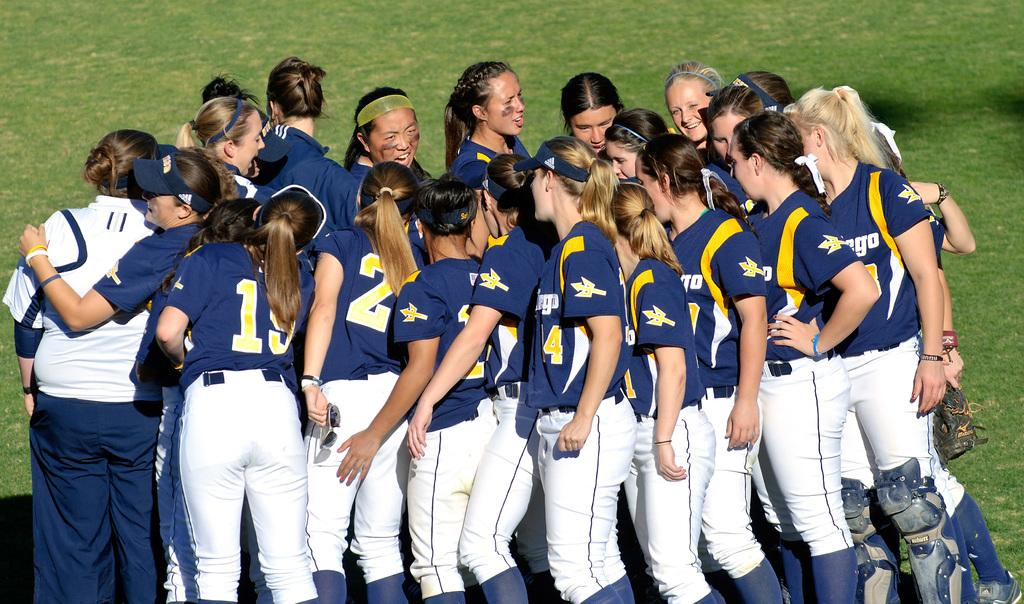<image>
Write a terse but informative summary of the picture. Many baseball players including number 2 standing in a huddle. 